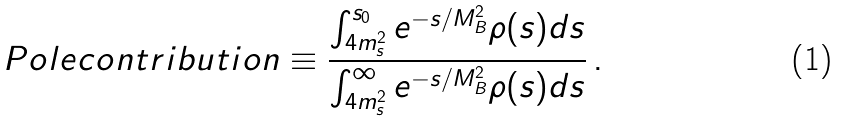Convert formula to latex. <formula><loc_0><loc_0><loc_500><loc_500>P o l e c o n t r i b u t i o n \equiv \frac { \int _ { 4 m _ { s } ^ { 2 } } ^ { s _ { 0 } } e ^ { - s / M _ { B } ^ { 2 } } \rho ( s ) d s } { \int _ { 4 m _ { s } ^ { 2 } } ^ { \infty } e ^ { - s / M _ { B } ^ { 2 } } \rho ( s ) d s } \, .</formula> 